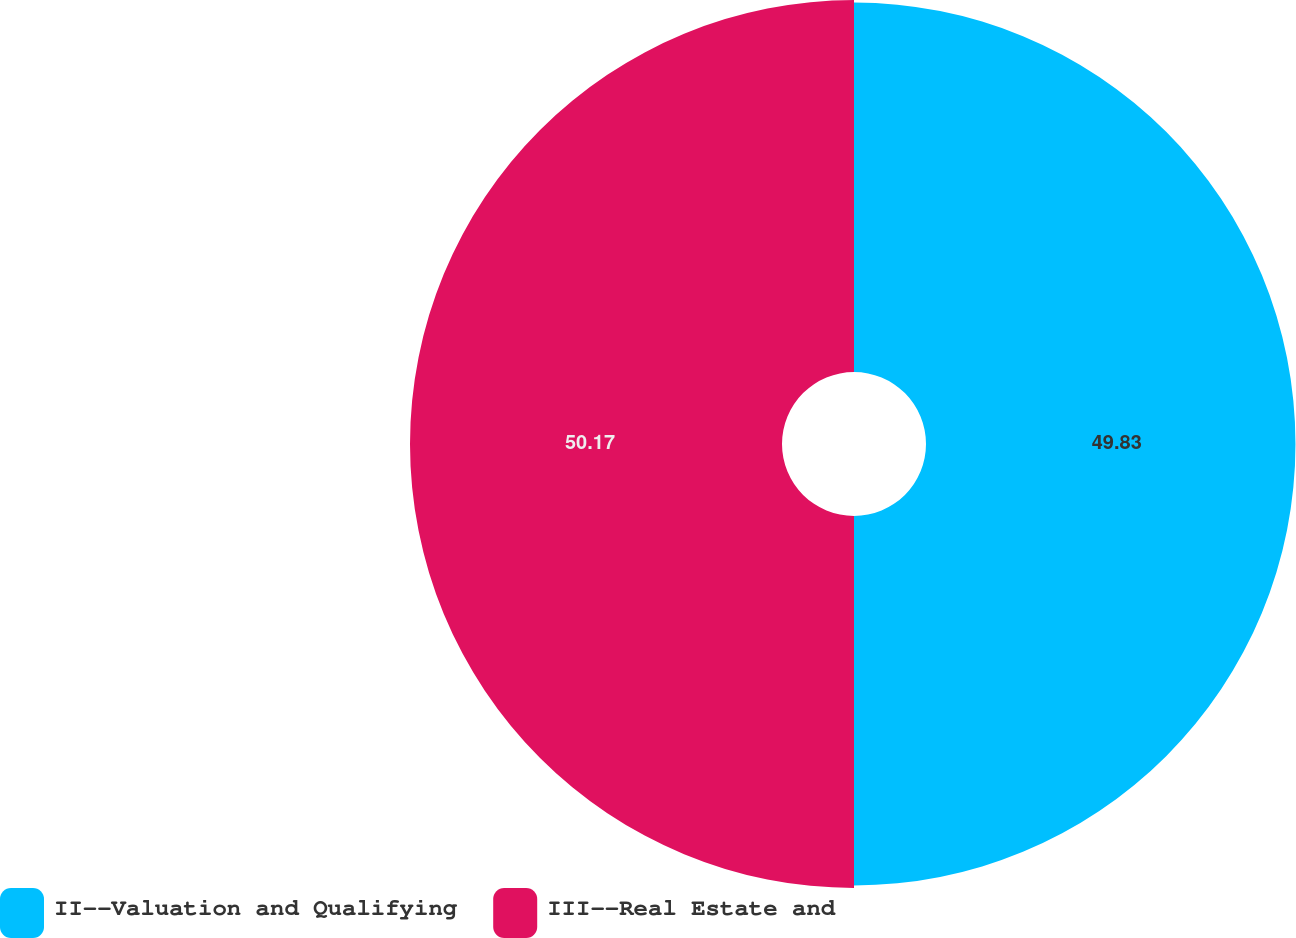Convert chart. <chart><loc_0><loc_0><loc_500><loc_500><pie_chart><fcel>II--Valuation and Qualifying<fcel>III--Real Estate and<nl><fcel>49.83%<fcel>50.17%<nl></chart> 